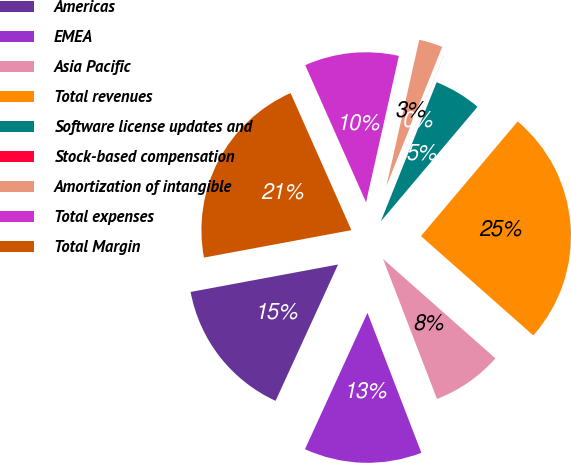<chart> <loc_0><loc_0><loc_500><loc_500><pie_chart><fcel>Americas<fcel>EMEA<fcel>Asia Pacific<fcel>Total revenues<fcel>Software license updates and<fcel>Stock-based compensation<fcel>Amortization of intangible<fcel>Total expenses<fcel>Total Margin<nl><fcel>15.23%<fcel>12.69%<fcel>7.62%<fcel>25.37%<fcel>5.08%<fcel>0.01%<fcel>2.55%<fcel>10.16%<fcel>21.28%<nl></chart> 